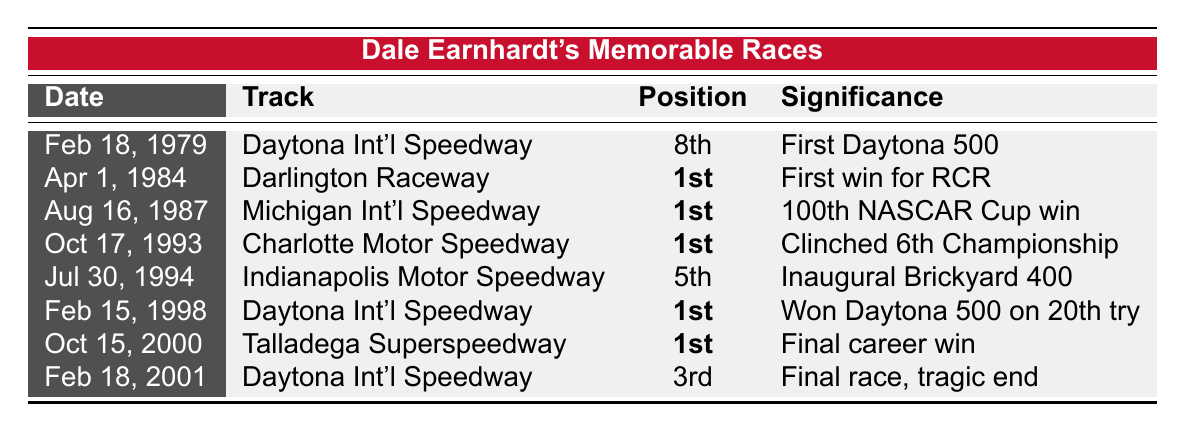What was Dale Earnhardt's finishing position in his first Daytona 500? The table shows that on February 18, 1979, at Daytona International Speedway, Dale Earnhardt finished in 8th position during his first Daytona 500.
Answer: 8th How many races did Dale Earnhardt win before he finally won the Daytona 500? According to the table, his first Daytona 500 was on February 18, 1979, and he won the Daytona 500 on February 15, 1998, meaning he entered 19 races in between where he did not win that specific race.
Answer: 19 races Which race marked Dale Earnhardt's 100th NASCAR Winston Cup win? The table indicates that on August 16, 1987, at Michigan International Speedway, Dale Earnhardt achieved his 100th NASCAR Winston Cup win.
Answer: Champion Spark Plug 400 Did Dale Earnhardt achieve a win at the inaugural Brickyard 400? From the table, it shows that on July 30, 1994, Dale Earnhardt finished 5th in the Brickyard 400, not a win. Therefore, the answer is no.
Answer: No What was significant about Dale Earnhardt's final race on February 18, 2001? The table states that this race was his final race, and it ended in a tragic fatal crash. This indicates great significance and emotional weight.
Answer: Final race, tragic end How many races did Dale Earnhardt finish in 1st position according to the table? The table lists 4 races where he achieved a 1st place finish, specifically on April 1, 1984, August 16, 1987, October 17, 1993, and February 15, 1998.
Answer: 4 races What is the time span between Dale Earnhardt's first and last race mentioned in the table? The first race listed is on February 18, 1979, and the last race is on February 18, 2001, indicating a timespan of 22 years.
Answer: 22 years Which race did he clinch his 6th Winston Cup Championship? Looking at the data, it shows that he clinched his 6th Championship on October 17, 1993, at Charlotte Motor Speedway.
Answer: Mello Yello 500 What position did Dale Earnhardt finish in his last career race? The table reveals that in his final race on February 18, 2001, Dale Earnhardt finished in 3rd position at Daytona International Speedway.
Answer: 3rd In which race did Dale Earnhardt win after starting from 18th place? The table indicates that on October 15, 2000, during the Winston 500 at Talladega Superspeedway, he won the race after starting from 18th place.
Answer: Winston 500 What is the significance of Dale Earnhardt's victory on February 15, 1998? In the table, it states this victory was significant as it marked his first win at the Daytona 500 after 20 attempts, which is a notable achievement in his career.
Answer: Won Daytona 500 on 20th try 